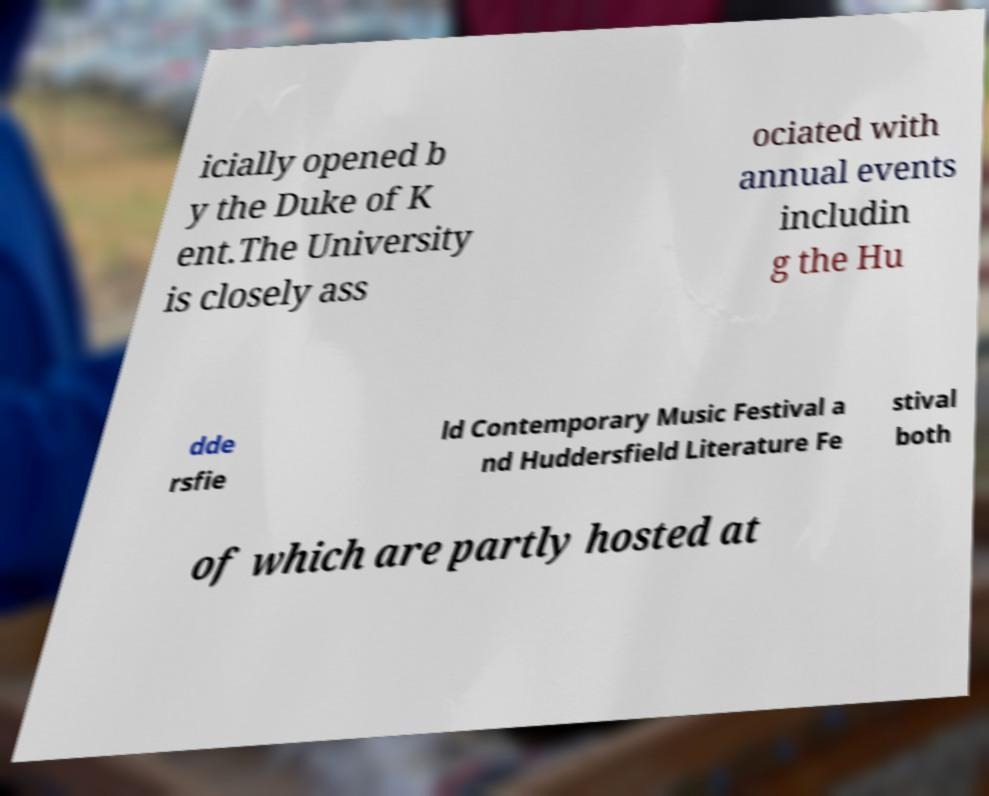Could you extract and type out the text from this image? icially opened b y the Duke of K ent.The University is closely ass ociated with annual events includin g the Hu dde rsfie ld Contemporary Music Festival a nd Huddersfield Literature Fe stival both of which are partly hosted at 